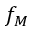<formula> <loc_0><loc_0><loc_500><loc_500>f _ { M }</formula> 